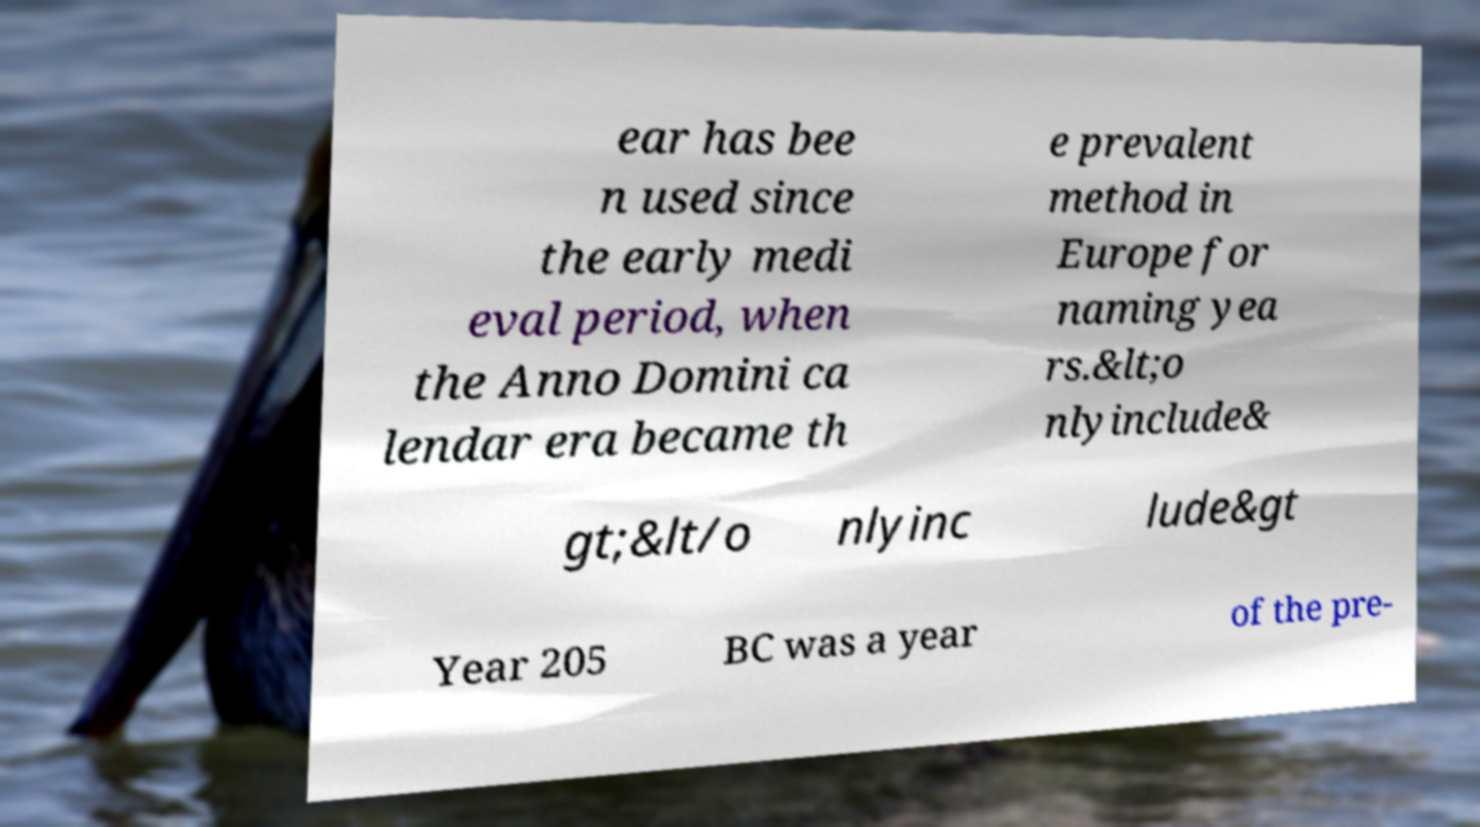For documentation purposes, I need the text within this image transcribed. Could you provide that? ear has bee n used since the early medi eval period, when the Anno Domini ca lendar era became th e prevalent method in Europe for naming yea rs.&lt;o nlyinclude& gt;&lt/o nlyinc lude&gt Year 205 BC was a year of the pre- 